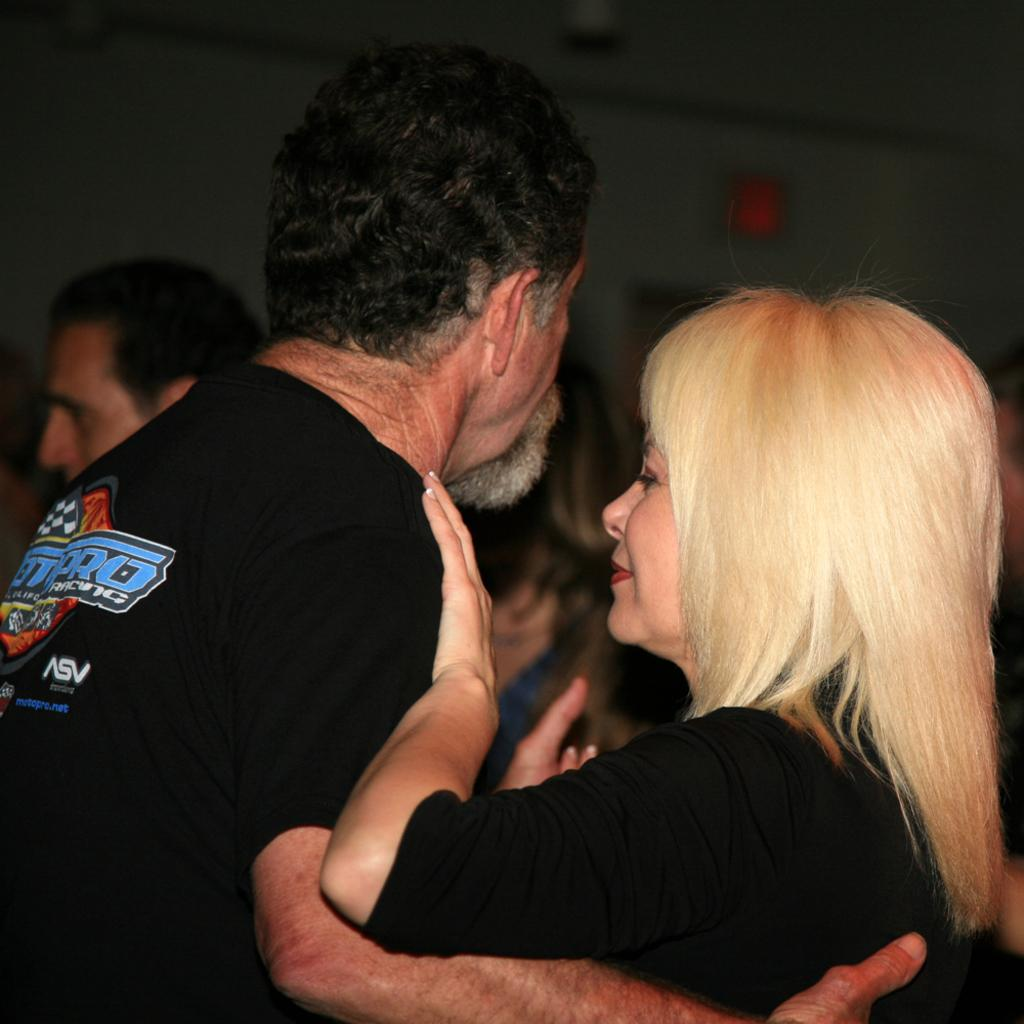Provide a one-sentence caption for the provided image. the man is wearing a tshirt with letters ASV on the right bottom corner. 